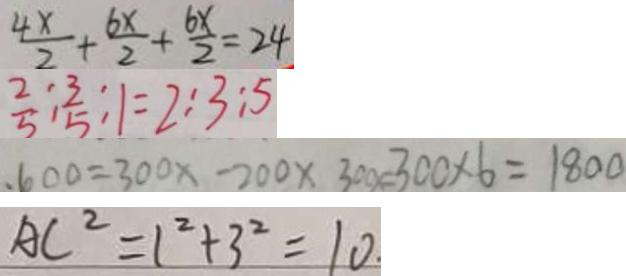<formula> <loc_0><loc_0><loc_500><loc_500>\frac { 4 x } { 2 } + \frac { 6 x } { 2 } + \frac { 6 x } { 2 } = 2 4 
 \frac { 2 } { 5 } : \frac { 3 } { 5 } : 1 = 2 : 3 : 5 
 . 6 0 0 = 3 0 0 x - 2 0 0 \times 3 0 0 x = 3 0 0 \times 6 = 1 8 0 0 
 A C ^ { 2 } = 1 ^ { 2 } + 3 ^ { 2 } = 1 0 .</formula> 